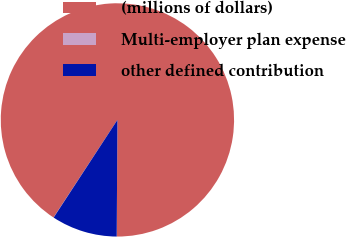Convert chart to OTSL. <chart><loc_0><loc_0><loc_500><loc_500><pie_chart><fcel>(millions of dollars)<fcel>Multi-employer plan expense<fcel>other defined contribution<nl><fcel>90.87%<fcel>0.02%<fcel>9.11%<nl></chart> 